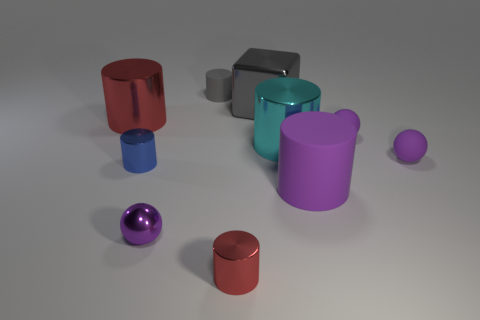Is the number of metal cylinders right of the tiny red shiny object less than the number of big red shiny objects left of the cyan metal object?
Offer a terse response. No. How many cylinders are either large red shiny objects or large gray metallic things?
Keep it short and to the point. 1. Do the small cylinder in front of the large purple matte thing and the gray object on the right side of the small gray object have the same material?
Offer a terse response. Yes. What is the shape of the matte object that is the same size as the cyan metal object?
Offer a terse response. Cylinder. How many other objects are there of the same color as the block?
Make the answer very short. 1. How many blue objects are either tiny rubber balls or tiny metallic cylinders?
Provide a succinct answer. 1. Is the shape of the purple object that is to the left of the gray cylinder the same as the red shiny object that is in front of the blue cylinder?
Offer a terse response. No. How many other things are there of the same material as the big gray block?
Ensure brevity in your answer.  5. There is a gray metallic thing that is right of the tiny blue metallic object that is on the left side of the cyan metal object; are there any blue metallic things that are behind it?
Offer a terse response. No. Is the material of the large cyan object the same as the small blue cylinder?
Offer a very short reply. Yes. 